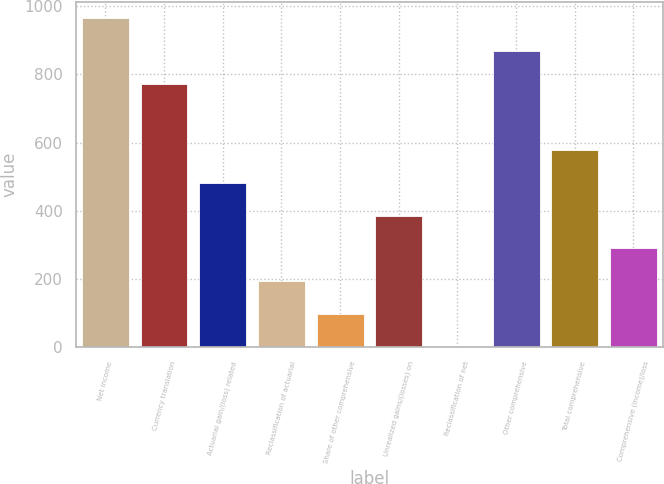Convert chart to OTSL. <chart><loc_0><loc_0><loc_500><loc_500><bar_chart><fcel>Net income<fcel>Currency translation<fcel>Actuarial gain/(loss) related<fcel>Reclassification of actuarial<fcel>Share of other comprehensive<fcel>Unrealized gains/(losses) on<fcel>Reclassification of net<fcel>Other comprehensive<fcel>Total comprehensive<fcel>Comprehensive (income)/loss<nl><fcel>964.1<fcel>771.36<fcel>482.25<fcel>193.14<fcel>96.77<fcel>385.88<fcel>0.4<fcel>867.73<fcel>578.62<fcel>289.51<nl></chart> 